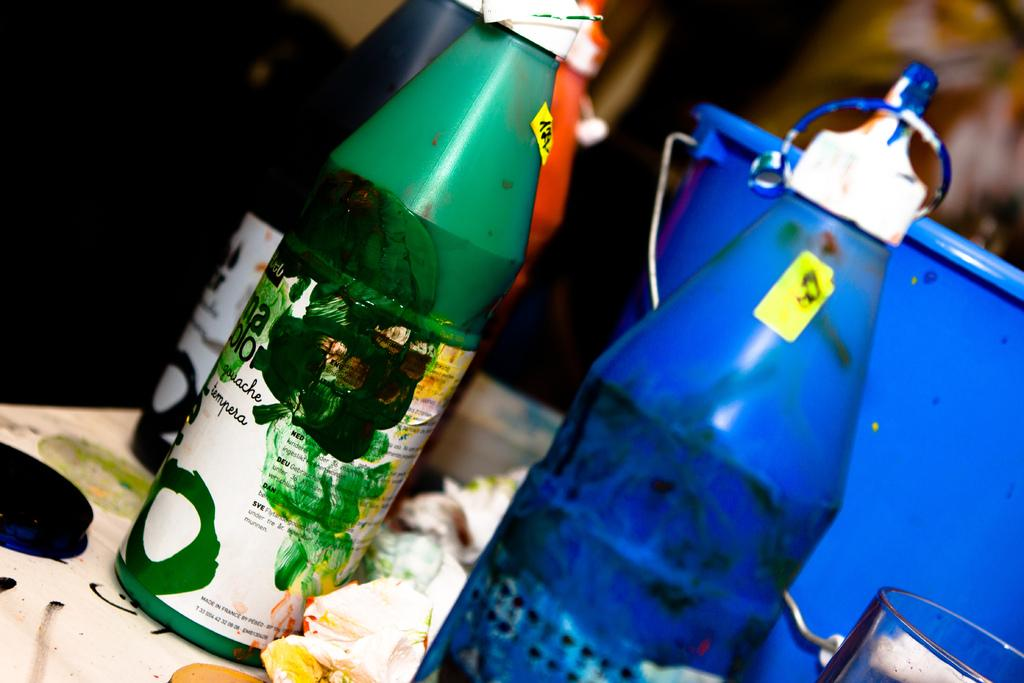What type of objects are present on the table in the image? There are color bottles and a bucket on the table in the image. What is the purpose of the bucket in the image? The purpose of the bucket in the image is not explicitly stated, but it could be used for holding or carrying items. How many color bottles are visible in the image? The number of color bottles is not specified, but there are at least two bottles present. What is the annual income of the person who owns the color bottles in the image? There is no information about the owner of the color bottles or their income in the image. 